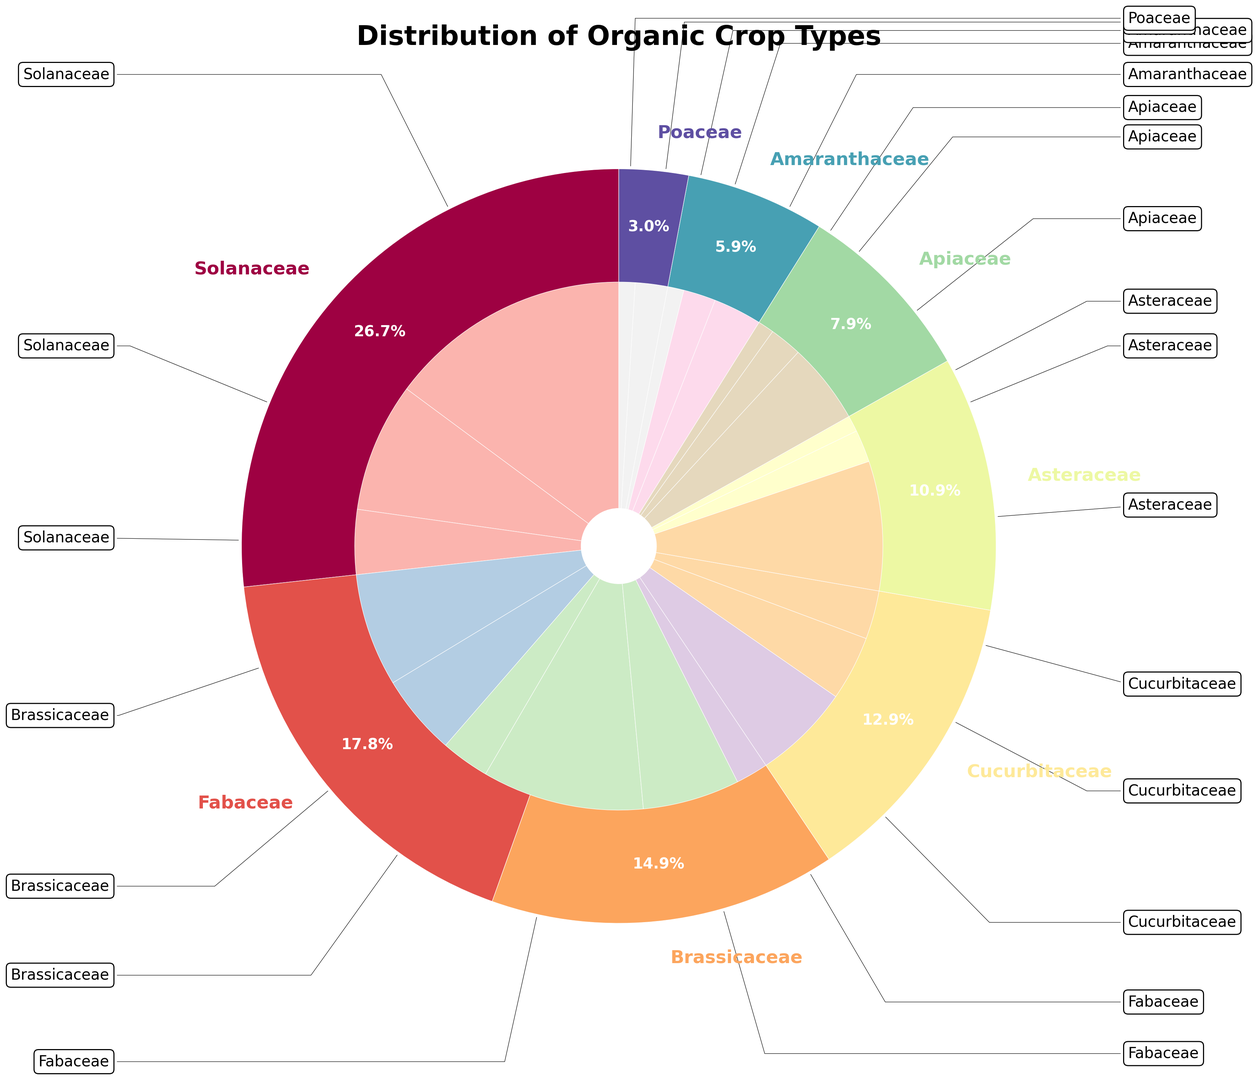What percentage of total crop types does the Fabaceae family account for? To find the percentage of total crop types that the Fabaceae family accounts for, locate the wedge for Fabaceae in the outer ring of the pie chart and read its corresponding percentage label.
Answer: 18% Which crop contributes the highest percentage within the Solanaceae family? In the inner ring of the pie chart, locate the crops within the Solanaceae family and identify the percentage of each. The crop with the highest percentage is Tomatoes.
Answer: Tomatoes Compare the total percentage of crops in the Brassicaceae family to the Asteraceae family. Which has a higher percentage and by how much? Sum the individual percentages for crops in the Brassicaceae family (7% + 5% + 3%) and the Asteraceae family (8% + 2% + 1%). Compare these sums to find which family has a higher percentage and by how much.
Answer: Asteraceae, by 1% Which family has a larger share, Cucurbitaceae or Poaceae, and what is the difference in percentage points? Compare the total percentages from the outer ring wedges of Cucurbitaceae (6% + 4% + 3%) and Poaceae (2% + 1%). Subtract the smaller percentage total from the larger one to find the difference.
Answer: Cucurbitaceae, by 10% Within the Apiaceae family, are there more crops that have a percentage of 2% each or 1% each? Check the Apiaceae family and note the number of crops with 2% each (2 crops: Celery, Parsnips) and the number of crops with 1% each (1 crop: Parsnips). Compare the counts.
Answer: 2% each Which family has the smallest representation in terms of percentage, and what is its total percentage? Find the family with the smallest wedge in the outer ring of the pie chart and note its total percentage.
Answer: Poaceae, 3% If the Solanaceae and Brassicaceae percentages are combined, what is the total percentage, and how does it compare to the combined Fabaceae and Cucurbitaceae percentages? Add the percentages of Solanaceae (15% + 8% + 4%) and Brassicaceae (7% + 5% + 3%) to get their combined total. Do the same for Fabaceae (10% + 6% + 2%) and Cucurbitaceae (6% + 4% + 3%). Compare the two sums.
Answer: Solanaceae + Brassicaceae: 42%, Fabaceae + Cucurbitaceae: 31% What is the ratio of the total percentage of crops in the Amaranthaceae family to the percentage of Tomatoes in Solanaceae? Find the total percentage for the Amaranthaceae family (3% + 2% + 1%) and compare it to the percentage of Tomatoes in the Solanaceae family (15%). The ratio is 6% to 15%.
Answer: 2:5 